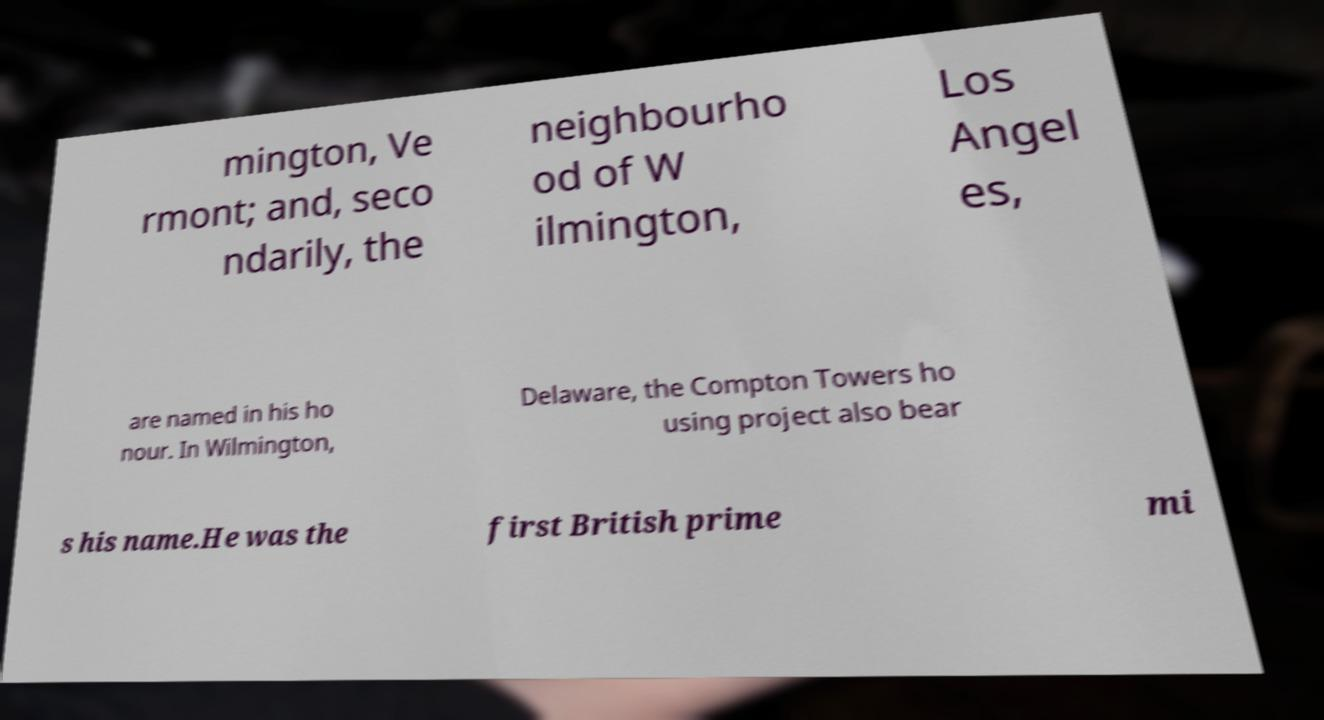Can you accurately transcribe the text from the provided image for me? mington, Ve rmont; and, seco ndarily, the neighbourho od of W ilmington, Los Angel es, are named in his ho nour. In Wilmington, Delaware, the Compton Towers ho using project also bear s his name.He was the first British prime mi 